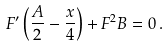Convert formula to latex. <formula><loc_0><loc_0><loc_500><loc_500>F ^ { \prime } \left ( \frac { A } { 2 } - \frac { x } { 4 } \right ) + F ^ { 2 } B = 0 \, .</formula> 